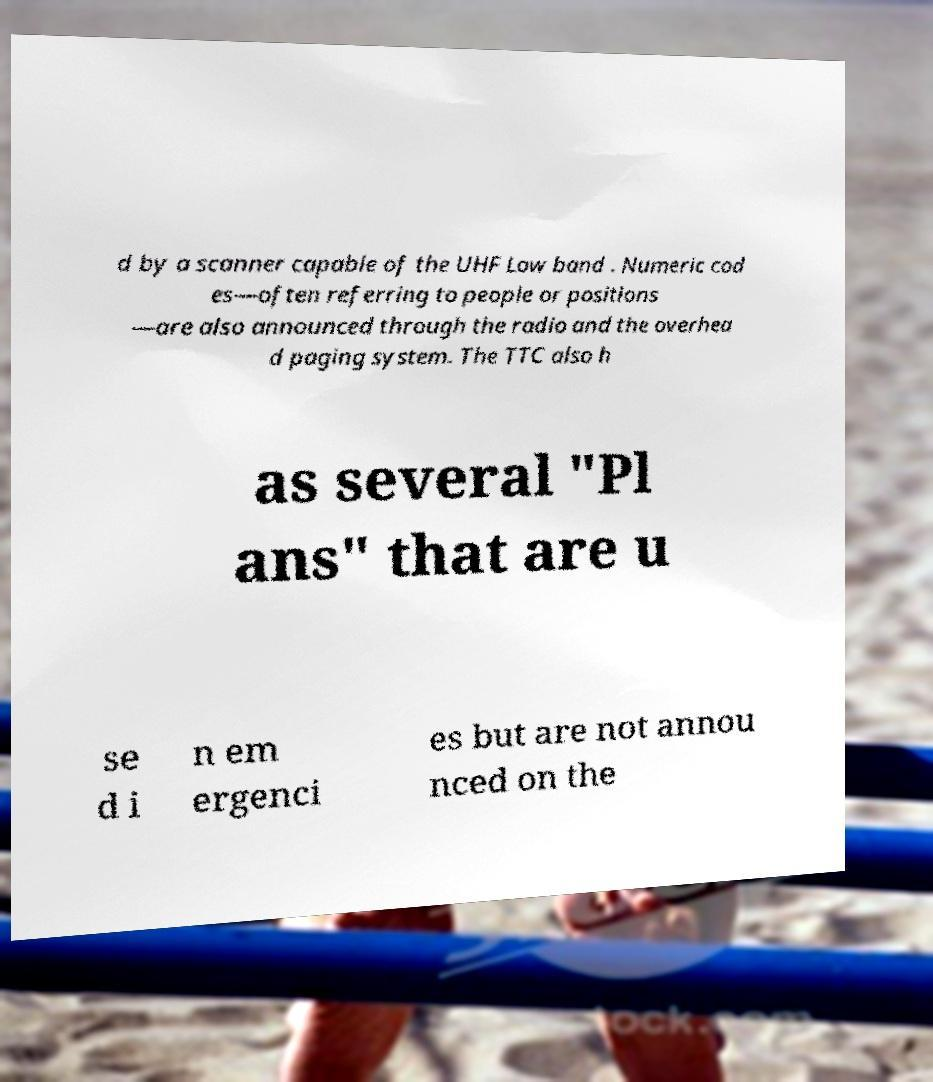For documentation purposes, I need the text within this image transcribed. Could you provide that? d by a scanner capable of the UHF Low band . Numeric cod es—often referring to people or positions —are also announced through the radio and the overhea d paging system. The TTC also h as several "Pl ans" that are u se d i n em ergenci es but are not annou nced on the 